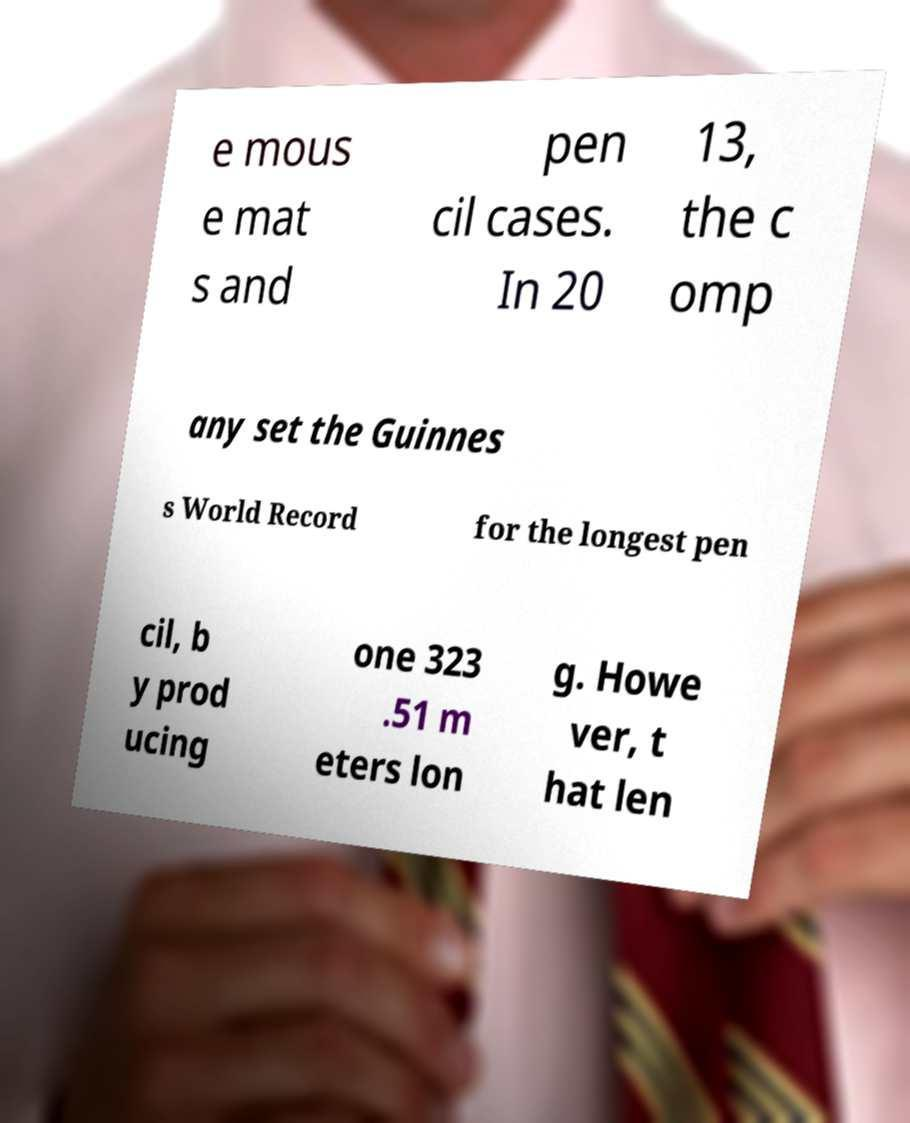There's text embedded in this image that I need extracted. Can you transcribe it verbatim? e mous e mat s and pen cil cases. In 20 13, the c omp any set the Guinnes s World Record for the longest pen cil, b y prod ucing one 323 .51 m eters lon g. Howe ver, t hat len 